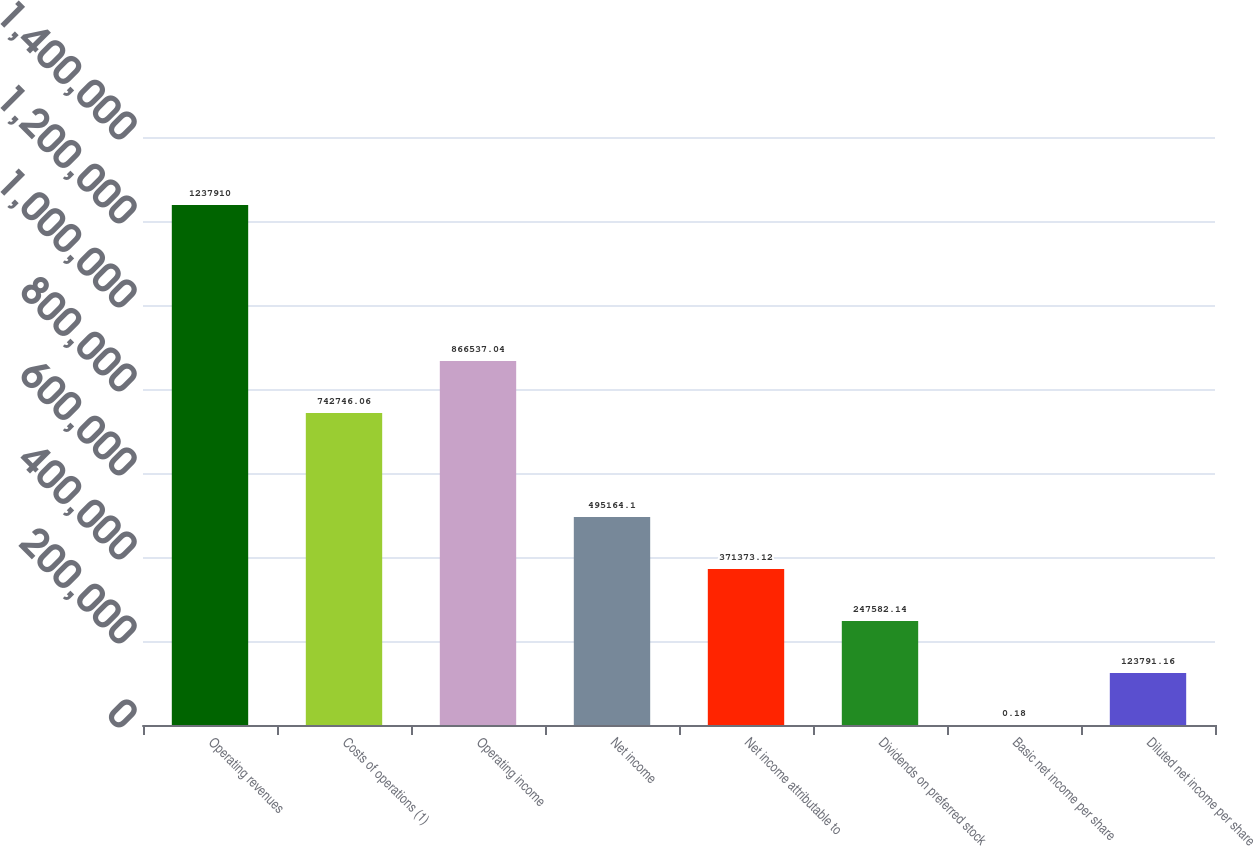Convert chart. <chart><loc_0><loc_0><loc_500><loc_500><bar_chart><fcel>Operating revenues<fcel>Costs of operations (1)<fcel>Operating income<fcel>Net income<fcel>Net income attributable to<fcel>Dividends on preferred stock<fcel>Basic net income per share<fcel>Diluted net income per share<nl><fcel>1.23791e+06<fcel>742746<fcel>866537<fcel>495164<fcel>371373<fcel>247582<fcel>0.18<fcel>123791<nl></chart> 